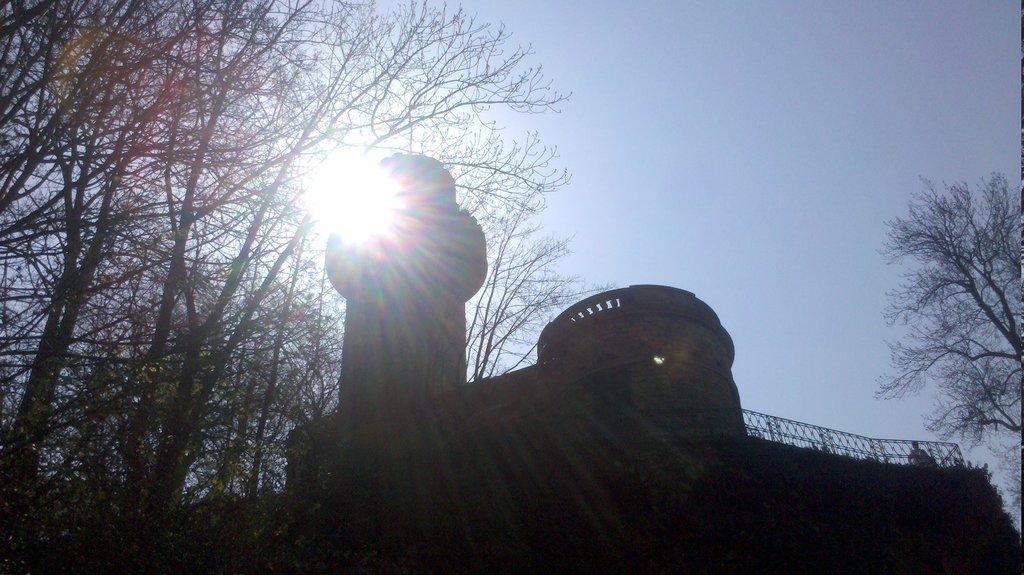Describe this image in one or two sentences. In this image in the center there is a building, and on the right side and left side there are trees. At the top there is sky, and on the right side of the building there is a railing. 